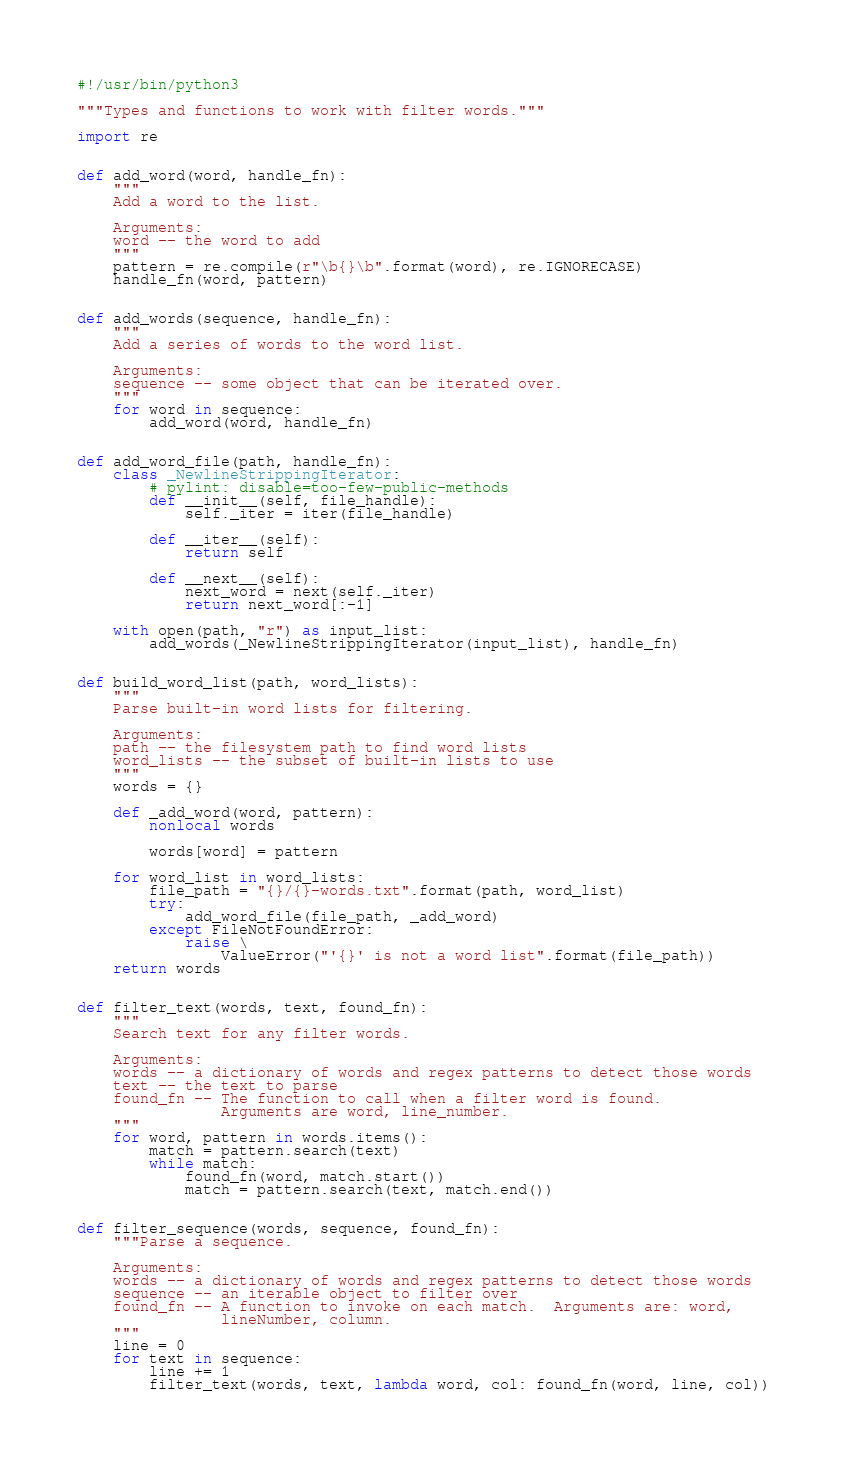<code> <loc_0><loc_0><loc_500><loc_500><_Python_>#!/usr/bin/python3

"""Types and functions to work with filter words."""

import re


def add_word(word, handle_fn):
    """
    Add a word to the list.

    Arguments:
    word -- the word to add
    """
    pattern = re.compile(r"\b{}\b".format(word), re.IGNORECASE)
    handle_fn(word, pattern)


def add_words(sequence, handle_fn):
    """
    Add a series of words to the word list.

    Arguments:
    sequence -- some object that can be iterated over.
    """
    for word in sequence:
        add_word(word, handle_fn)


def add_word_file(path, handle_fn):
    class _NewlineStrippingIterator:
        # pylint: disable=too-few-public-methods
        def __init__(self, file_handle):
            self._iter = iter(file_handle)

        def __iter__(self):
            return self

        def __next__(self):
            next_word = next(self._iter)
            return next_word[:-1]

    with open(path, "r") as input_list:
        add_words(_NewlineStrippingIterator(input_list), handle_fn)


def build_word_list(path, word_lists):
    """
    Parse built-in word lists for filtering.

    Arguments:
    path -- the filesystem path to find word lists
    word_lists -- the subset of built-in lists to use
    """
    words = {}

    def _add_word(word, pattern):
        nonlocal words

        words[word] = pattern

    for word_list in word_lists:
        file_path = "{}/{}-words.txt".format(path, word_list)
        try:
            add_word_file(file_path, _add_word)
        except FileNotFoundError:
            raise \
                ValueError("'{}' is not a word list".format(file_path))
    return words


def filter_text(words, text, found_fn):
    """
    Search text for any filter words.

    Arguments:
    words -- a dictionary of words and regex patterns to detect those words
    text -- the text to parse
    found_fn -- The function to call when a filter word is found.
                Arguments are word, line_number.
    """
    for word, pattern in words.items():
        match = pattern.search(text)
        while match:
            found_fn(word, match.start())
            match = pattern.search(text, match.end())


def filter_sequence(words, sequence, found_fn):
    """Parse a sequence.

    Arguments:
    words -- a dictionary of words and regex patterns to detect those words
    sequence -- an iterable object to filter over
    found_fn -- A function to invoke on each match.  Arguments are: word,
                lineNumber, column.
    """
    line = 0
    for text in sequence:
        line += 1
        filter_text(words, text, lambda word, col: found_fn(word, line, col))
</code> 